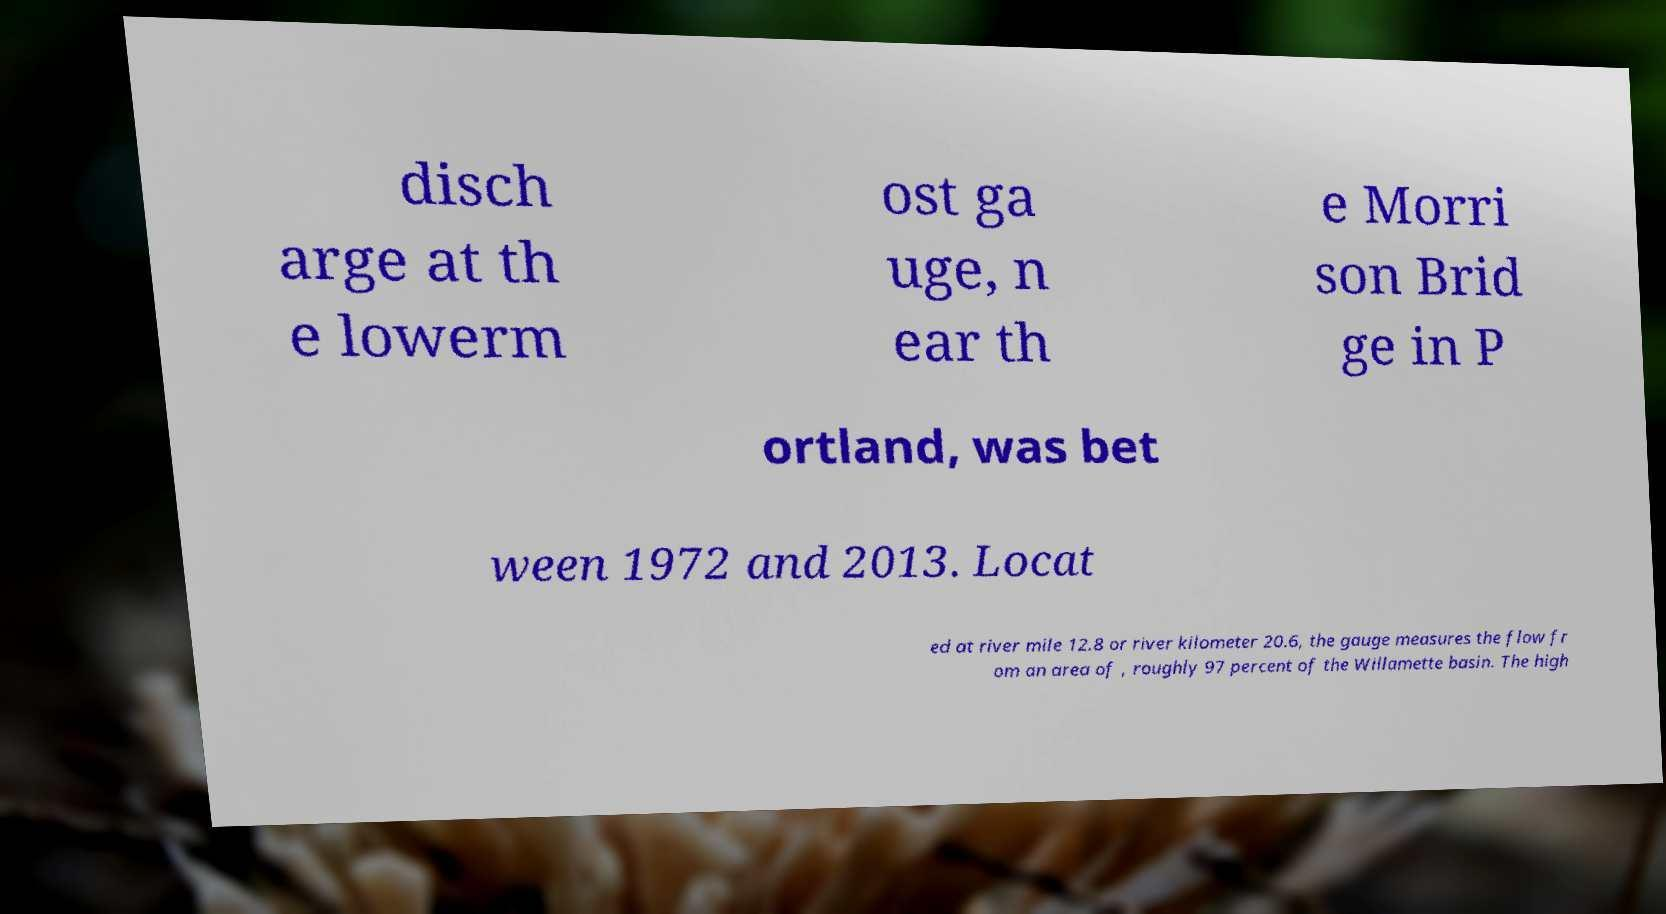Please read and relay the text visible in this image. What does it say? disch arge at th e lowerm ost ga uge, n ear th e Morri son Brid ge in P ortland, was bet ween 1972 and 2013. Locat ed at river mile 12.8 or river kilometer 20.6, the gauge measures the flow fr om an area of , roughly 97 percent of the Willamette basin. The high 